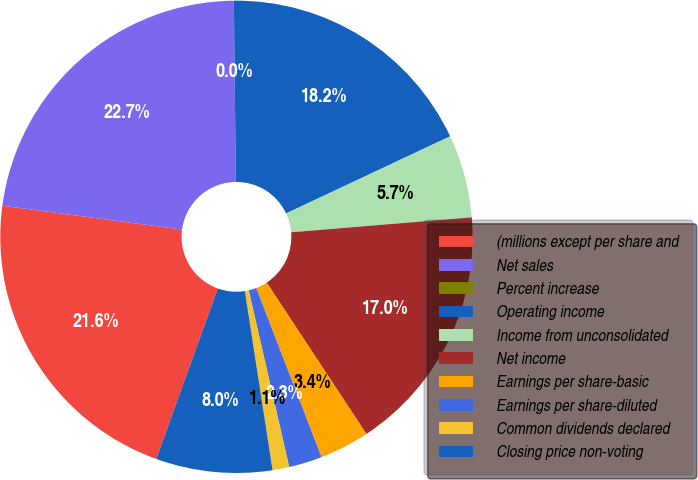Convert chart. <chart><loc_0><loc_0><loc_500><loc_500><pie_chart><fcel>(millions except per share and<fcel>Net sales<fcel>Percent increase<fcel>Operating income<fcel>Income from unconsolidated<fcel>Net income<fcel>Earnings per share-basic<fcel>Earnings per share-diluted<fcel>Common dividends declared<fcel>Closing price non-voting<nl><fcel>21.59%<fcel>22.72%<fcel>0.0%<fcel>18.18%<fcel>5.68%<fcel>17.04%<fcel>3.41%<fcel>2.28%<fcel>1.14%<fcel>7.96%<nl></chart> 